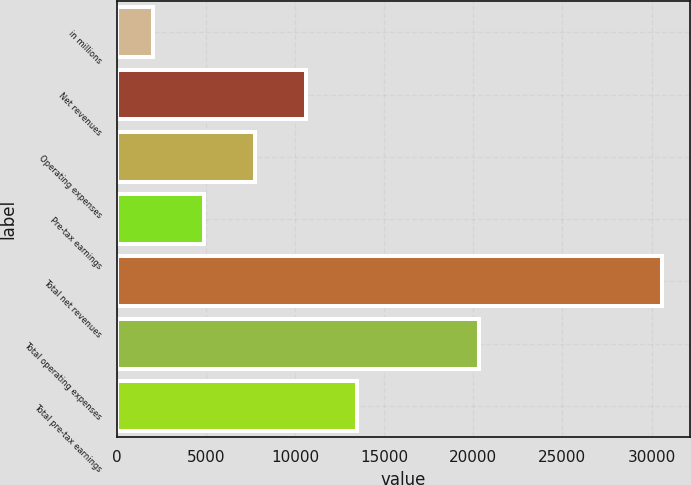Convert chart to OTSL. <chart><loc_0><loc_0><loc_500><loc_500><bar_chart><fcel>in millions<fcel>Net revenues<fcel>Operating expenses<fcel>Pre-tax earnings<fcel>Total net revenues<fcel>Total operating expenses<fcel>Total pre-tax earnings<nl><fcel>2016<fcel>10593.6<fcel>7734.4<fcel>4875.2<fcel>30608<fcel>20304<fcel>13452.8<nl></chart> 